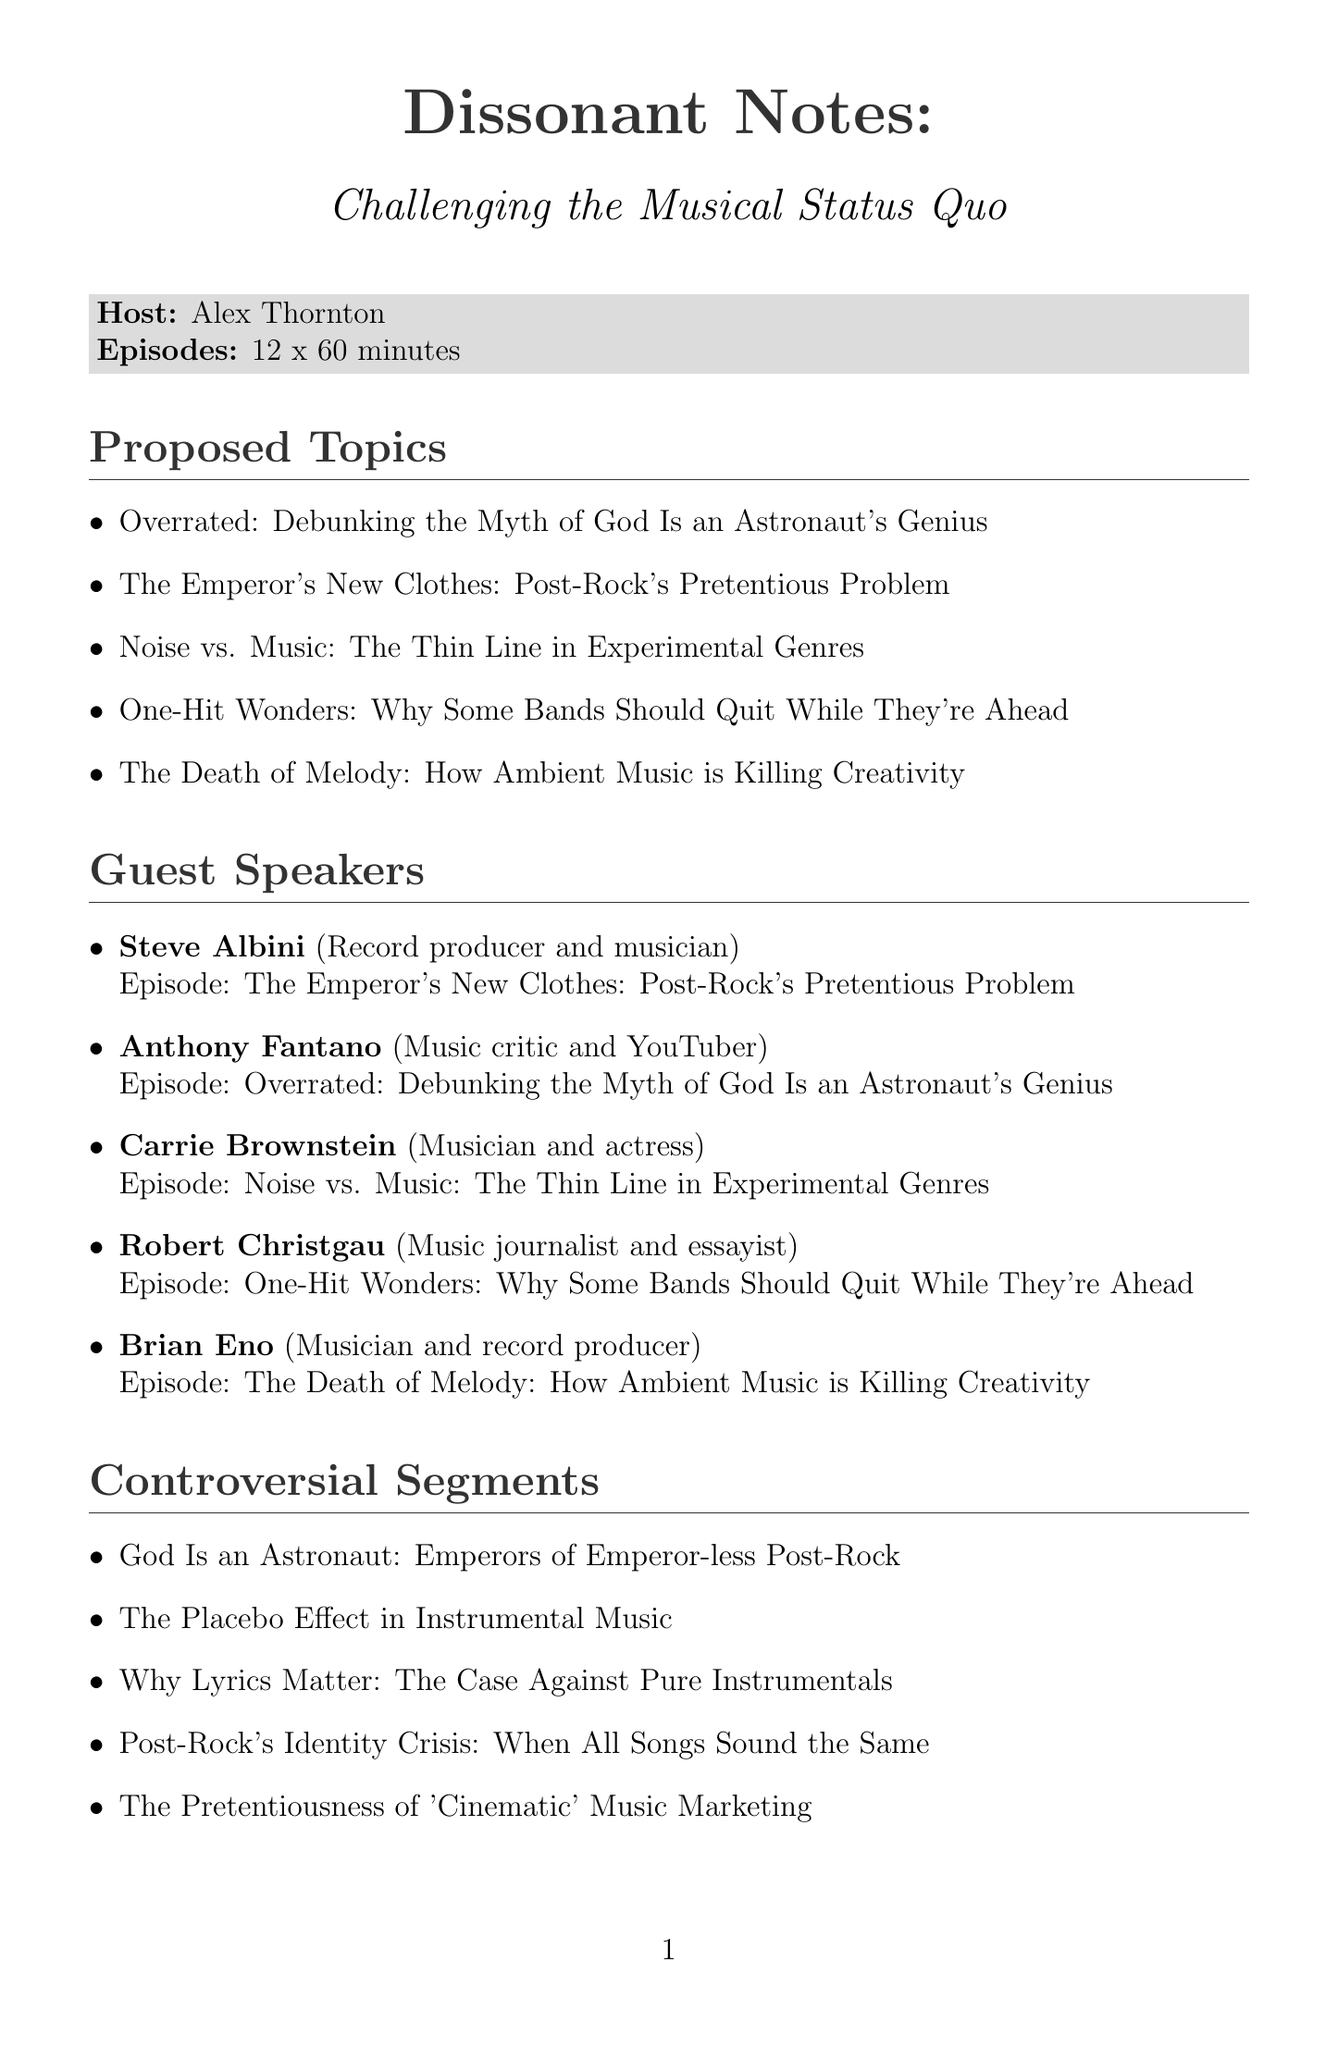What is the title of the podcast? The title of the podcast is explicitly stated at the beginning of the document.
Answer: Dissonant Notes: Challenging the Musical Status Quo Who is the host of the podcast? The host's name is listed under the podcast details in the document.
Answer: Alex Thornton How many episodes will the podcast have? The number of episodes is mentioned in the podcast details section.
Answer: 12 What is the duration of each episode? The episode duration is provided as part of the podcast details.
Answer: 60 minutes Which guest speaker will discuss "Noise vs. Music: The Thin Line in Experimental Genres"? The relevant guest speaker's information is found in the guest speakers section.
Answer: Carrie Brownstein What is one of the proposed topics for the podcast? Proposed topics are listed in their own section of the document.
Answer: Overrated: Debunking the Myth of God Is an Astronaut's Genius What are the target audience demographics? The target audience is described in a specific section of the document.
Answer: Music enthusiasts aged 25-45 What is one of the marketing strategies mentioned? Marketing strategies are listed, with specific examples included.
Answer: Provocative social media teasers Which funding option includes merchandise sales? Funding options detail various financial support methods in the document.
Answer: Merchandise sales (t-shirts, stickers, etc.) What distribution platforms will the podcast be available on? The document provides a list of all platforms where the podcast can be found.
Answer: Spotify, Apple Podcasts, Google Podcasts, YouTube, SoundCloud 